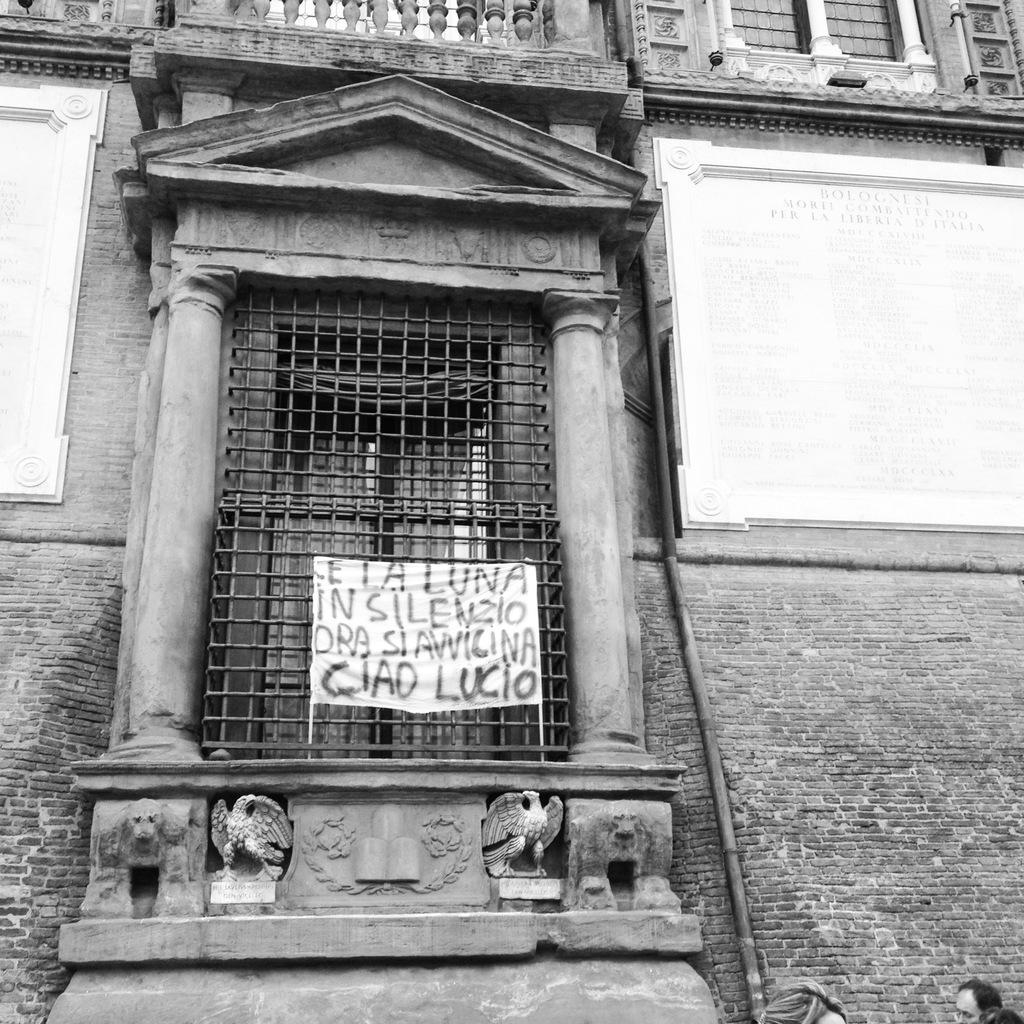What type of structure is present in the image? There is a building in the image. What feature can be seen on the building? The building has windows. What additional object is present in the image? There is a banner in the image. What is one of the main components of the building? The building has a wall. What other objects can be seen in the image? There are pipes in the image. Are there any people present in the image? Yes, there are persons in the image. What type of bait is being used by the cows in the image? There are no cows present in the image, so there is no bait being used. 